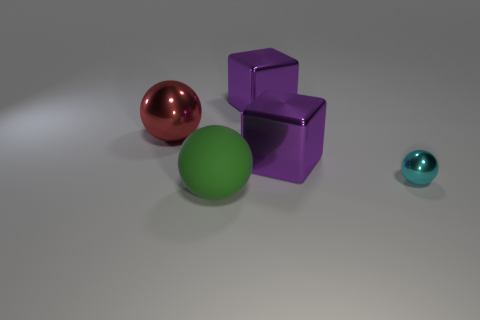Are there any other things that are the same size as the cyan metallic object?
Your answer should be compact. No. Are there any other things that are made of the same material as the large green sphere?
Provide a succinct answer. No. How many other things are there of the same shape as the big matte thing?
Offer a very short reply. 2. How many large red metal objects are to the left of the red object?
Make the answer very short. 0. What is the size of the sphere that is right of the big red shiny sphere and behind the matte sphere?
Offer a very short reply. Small. Are there any rubber spheres?
Provide a succinct answer. Yes. What number of other objects are the same size as the cyan metal ball?
Your answer should be very brief. 0. Is the color of the metallic object behind the red metallic sphere the same as the large cube that is in front of the red metal thing?
Ensure brevity in your answer.  Yes. What is the size of the red metallic object that is the same shape as the big matte thing?
Offer a very short reply. Large. Is the material of the ball that is to the left of the green rubber ball the same as the tiny cyan thing that is to the right of the big green thing?
Your answer should be compact. Yes. 